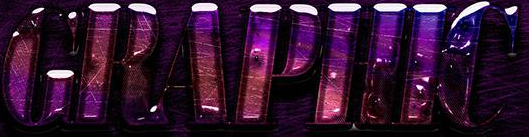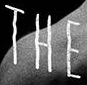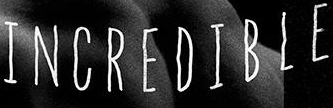Read the text from these images in sequence, separated by a semicolon. GRAPHIC; THE; INCREDIBLE 